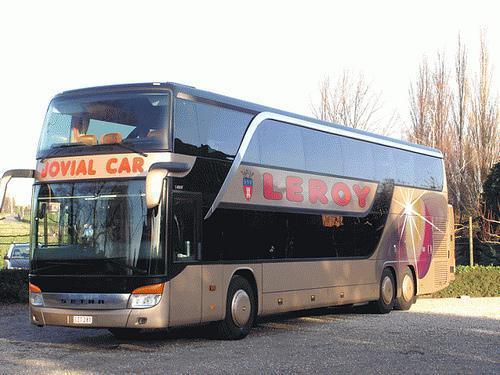How many wheels are on the bus?
Give a very brief answer. 6. How many giraffes are in the photo?
Give a very brief answer. 0. 